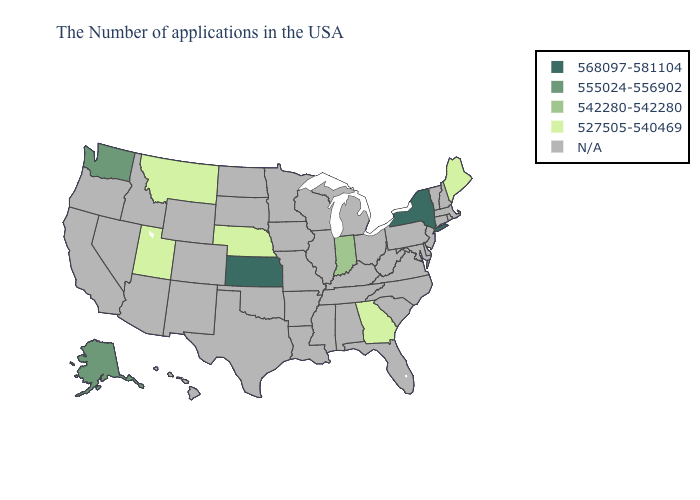Does Utah have the highest value in the West?
Short answer required. No. What is the value of North Dakota?
Be succinct. N/A. Name the states that have a value in the range 542280-542280?
Be succinct. Indiana. What is the lowest value in states that border Illinois?
Give a very brief answer. 542280-542280. Does Georgia have the highest value in the USA?
Give a very brief answer. No. What is the lowest value in states that border Ohio?
Write a very short answer. 542280-542280. What is the highest value in the USA?
Short answer required. 568097-581104. Name the states that have a value in the range 527505-540469?
Give a very brief answer. Maine, Georgia, Nebraska, Utah, Montana. What is the lowest value in the Northeast?
Keep it brief. 527505-540469. Name the states that have a value in the range 555024-556902?
Keep it brief. Washington, Alaska. Name the states that have a value in the range 527505-540469?
Concise answer only. Maine, Georgia, Nebraska, Utah, Montana. What is the value of Delaware?
Give a very brief answer. N/A. What is the value of Arkansas?
Short answer required. N/A. 